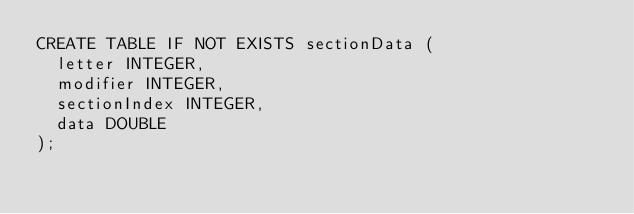<code> <loc_0><loc_0><loc_500><loc_500><_SQL_>CREATE TABLE IF NOT EXISTS sectionData (
  letter INTEGER,
  modifier INTEGER,
  sectionIndex INTEGER,
  data DOUBLE
);</code> 